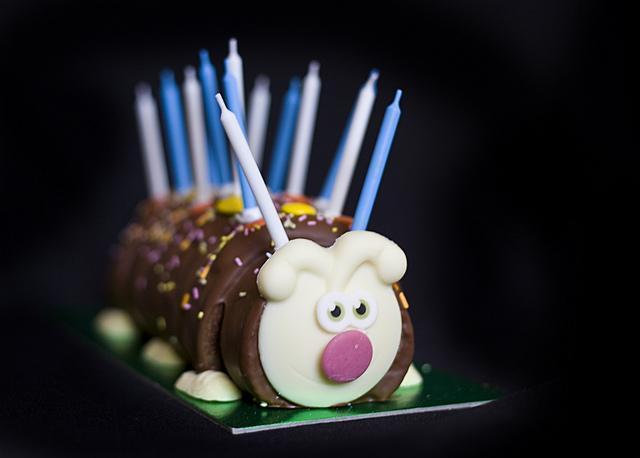How many people are in the water?
Give a very brief answer. 0. 